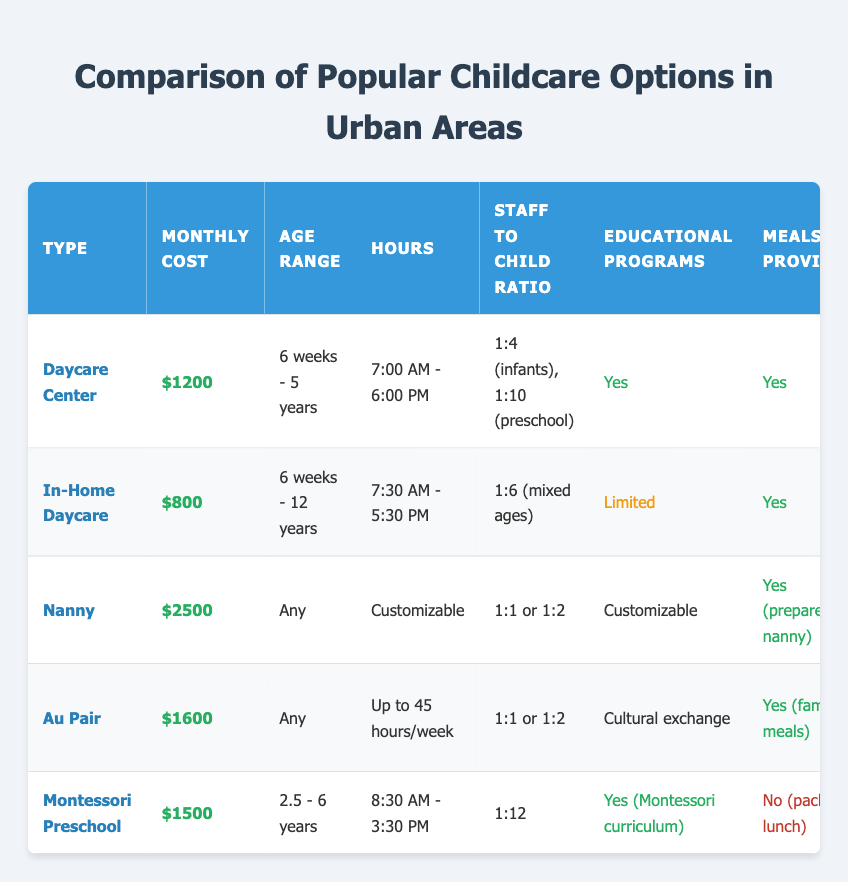What is the most expensive childcare option listed in the table? The childcare options listed include various types, and by comparing the average monthly costs, the Nanny costs $2500, which is the highest among all the options provided.
Answer: Nanny How many hours does the Au Pair provide childcare per week? The Au Pair option lists that it provides up to 45 hours of childcare a week, which is specified in the "Hours" column under that option.
Answer: Up to 45 hours/week Which provider offers flexible scheduling? The table indicates that the Nanny and Au Pair options have high flexible scheduling, as described in the "Flexible Scheduling" column for those specific types.
Answer: Nanny, Au Pair How much more expensive is the Daycare Center compared to In-Home Daycare? The Daycare Center costs $1200 and the In-Home Daycare costs $800. To find the difference, subtract: $1200 - $800 = $400. Therefore, the Daycare Center is $400 more expensive than the In-Home Daycare.
Answer: $400 Do all childcare options provide meals? By reviewing the "Meals Provided" column, we see that the Montessori Preschool does not provide meals (it indicates "No"), while all others have a "Yes" for meals provided. Therefore, not all options provide meals.
Answer: No What age range does the Montessori Preschool cater to? The Montessori Preschool specifies its age range as 2.5 - 6 years, which is shown in the "Age Range" column under that option.
Answer: 2.5 - 6 years Does the Daycare Center have a healthcare professional on-site? The "Healthcare Professional On-Site" column indicates "No" for the Daycare Center, indicating that it does not have a healthcare professional present.
Answer: No Which childcare option has the highest staff-to-child ratio, and what is it? The Nanny has a staff-to-child ratio of 1:1 or 1:2, which is the highest when compared to other options in the "Staff to Child Ratio" column. Therefore, the Nanny provides either one caregiver for one child or one caregiver for two children.
Answer: Nanny, 1:1 or 1:2 How many childcare options offer outdoor play areas? The "Outdoor Play Area" column shows that the Daycare Center, Montessori Preschool, and the options with Nanny and Au Pair mention varying outdoor resources. Therefore, there are four options that either explicitly state "Yes" or indicate varying outdoor resources.
Answer: Four options 